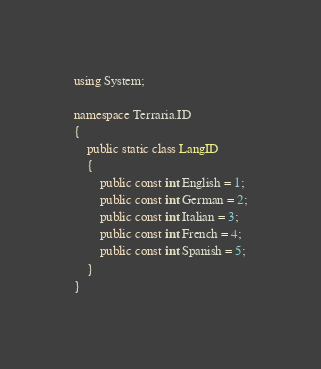Convert code to text. <code><loc_0><loc_0><loc_500><loc_500><_C#_>using System;

namespace Terraria.ID
{
	public static class LangID
	{
		public const int English = 1;
		public const int German = 2;
		public const int Italian = 3;
		public const int French = 4;
		public const int Spanish = 5;
	}
}
</code> 